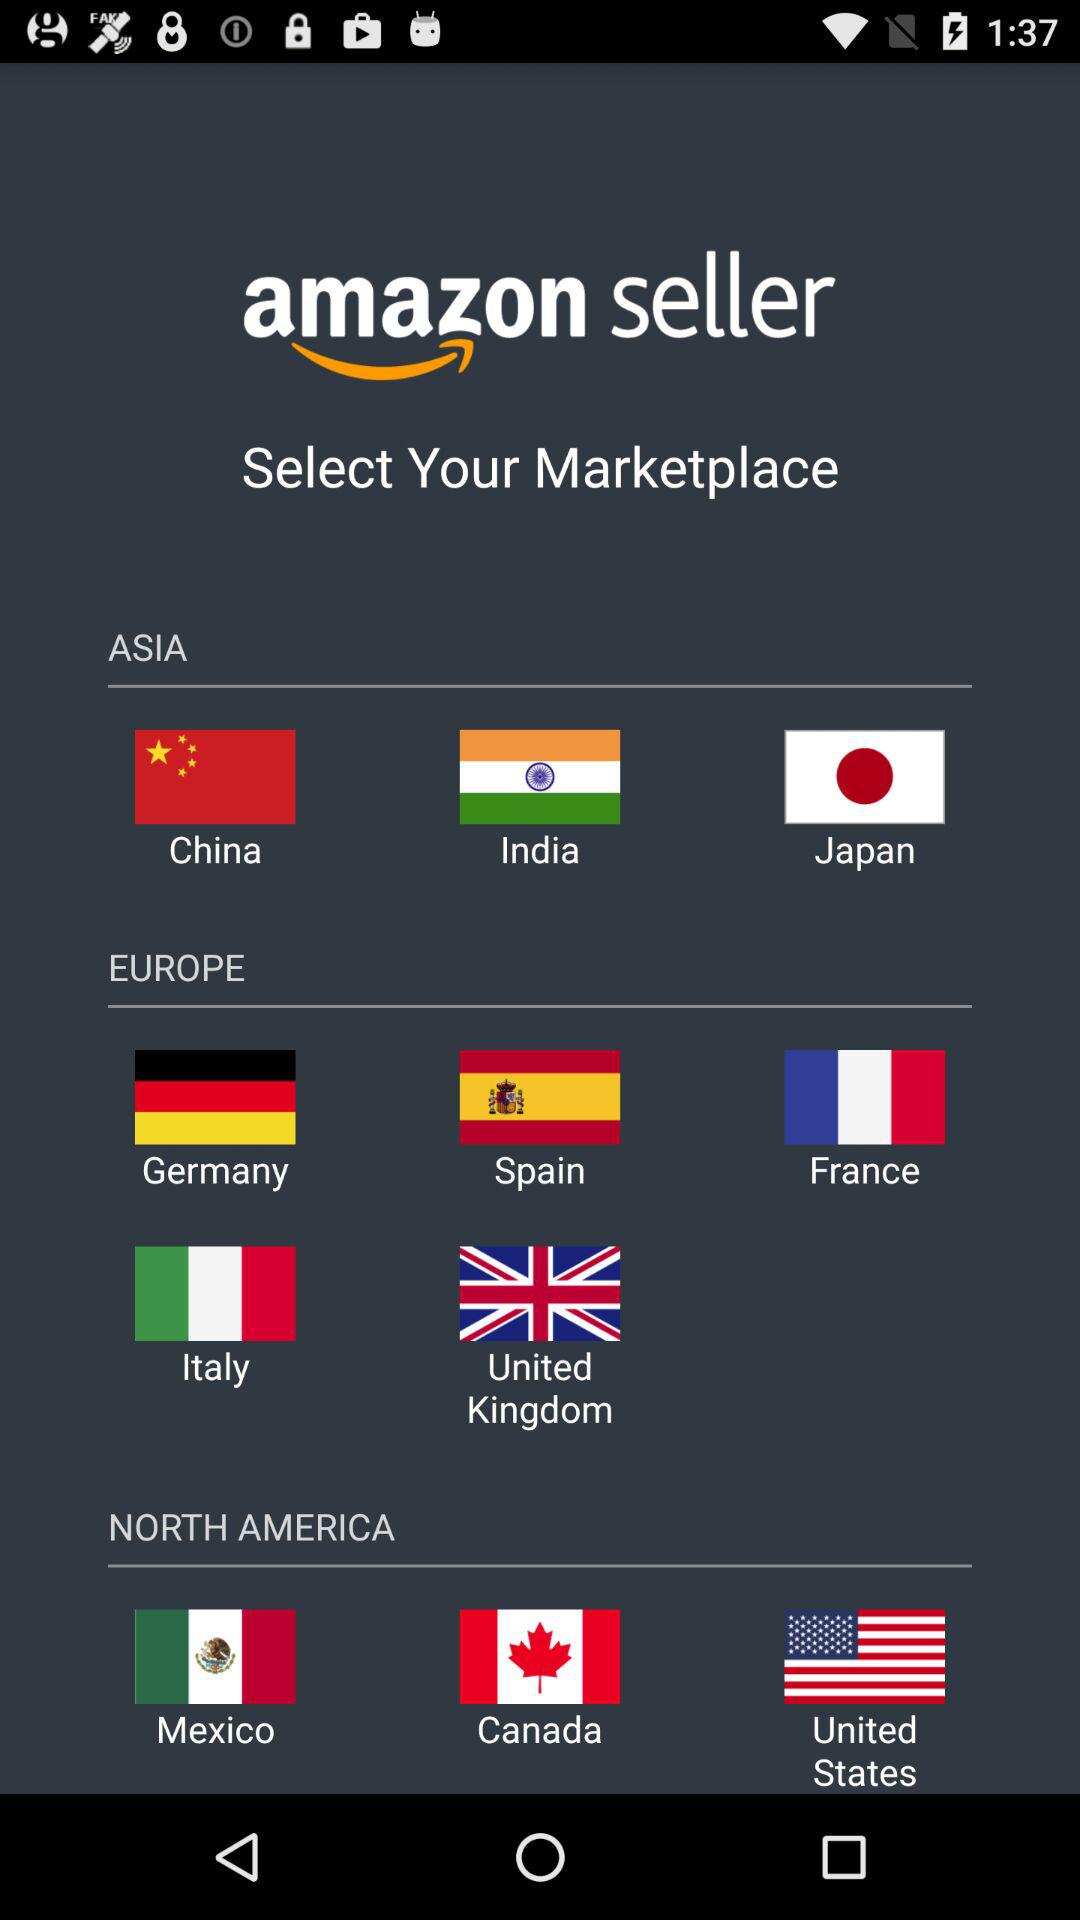In which continent does India come? India is on the continent of Asia. 